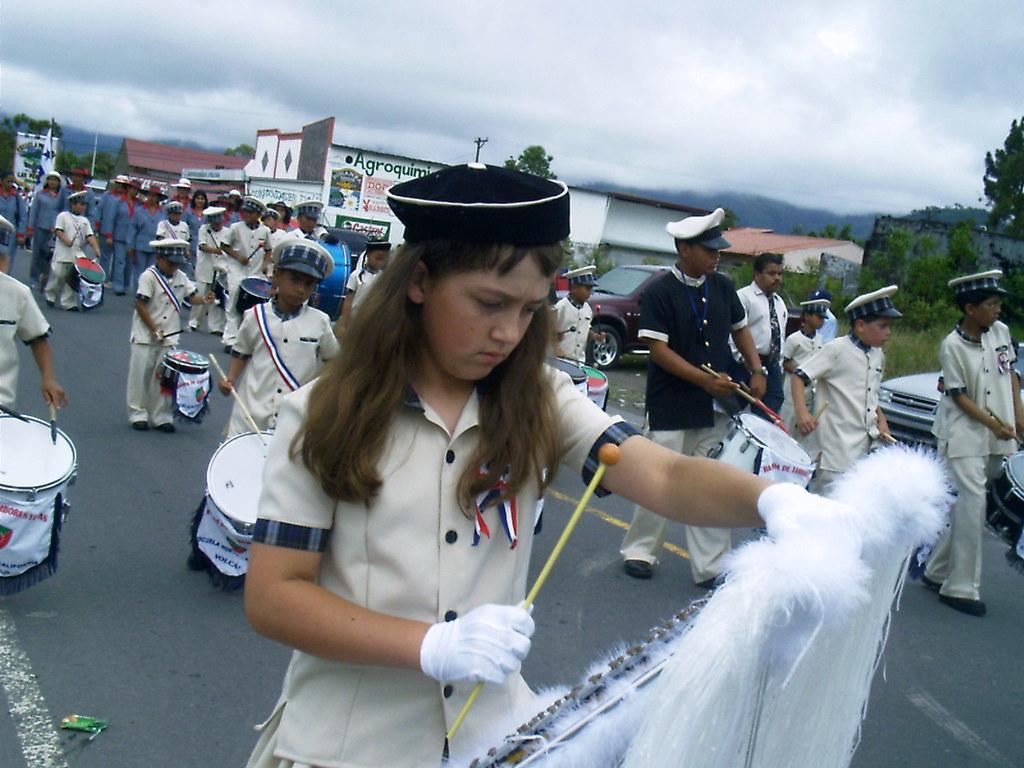How would you summarize this image in a sentence or two? In this image we can see these people wearing uniforms and caps are playing drums while walking on the road. In the background, we can see these people wearing blue dresses are walking on the road also we can see banners, a car parked here, grass, trees, houses and the cloudy sky. 